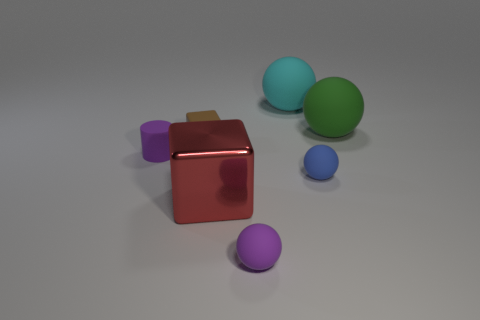What number of objects are red metal blocks or cyan rubber balls?
Your response must be concise. 2. There is a tiny rubber thing that is the same color as the tiny cylinder; what shape is it?
Give a very brief answer. Sphere. What size is the matte ball that is to the left of the small blue rubber object and in front of the large green rubber sphere?
Give a very brief answer. Small. What number of green rubber things are there?
Your response must be concise. 1. What number of cylinders are either purple things or small brown rubber objects?
Provide a succinct answer. 1. How many green matte spheres are in front of the purple thing to the left of the cube in front of the blue rubber sphere?
Provide a succinct answer. 0. There is a matte cube that is the same size as the matte cylinder; what is its color?
Offer a very short reply. Brown. What number of other objects are there of the same color as the small matte block?
Offer a terse response. 0. Are there more green objects behind the cyan matte sphere than tiny cyan spheres?
Offer a terse response. No. Do the tiny purple cylinder and the big red object have the same material?
Your response must be concise. No. 